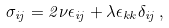<formula> <loc_0><loc_0><loc_500><loc_500>\sigma _ { i j } = 2 \nu \epsilon _ { i j } + \lambda \epsilon _ { k k } \delta _ { i j } \, ,</formula> 